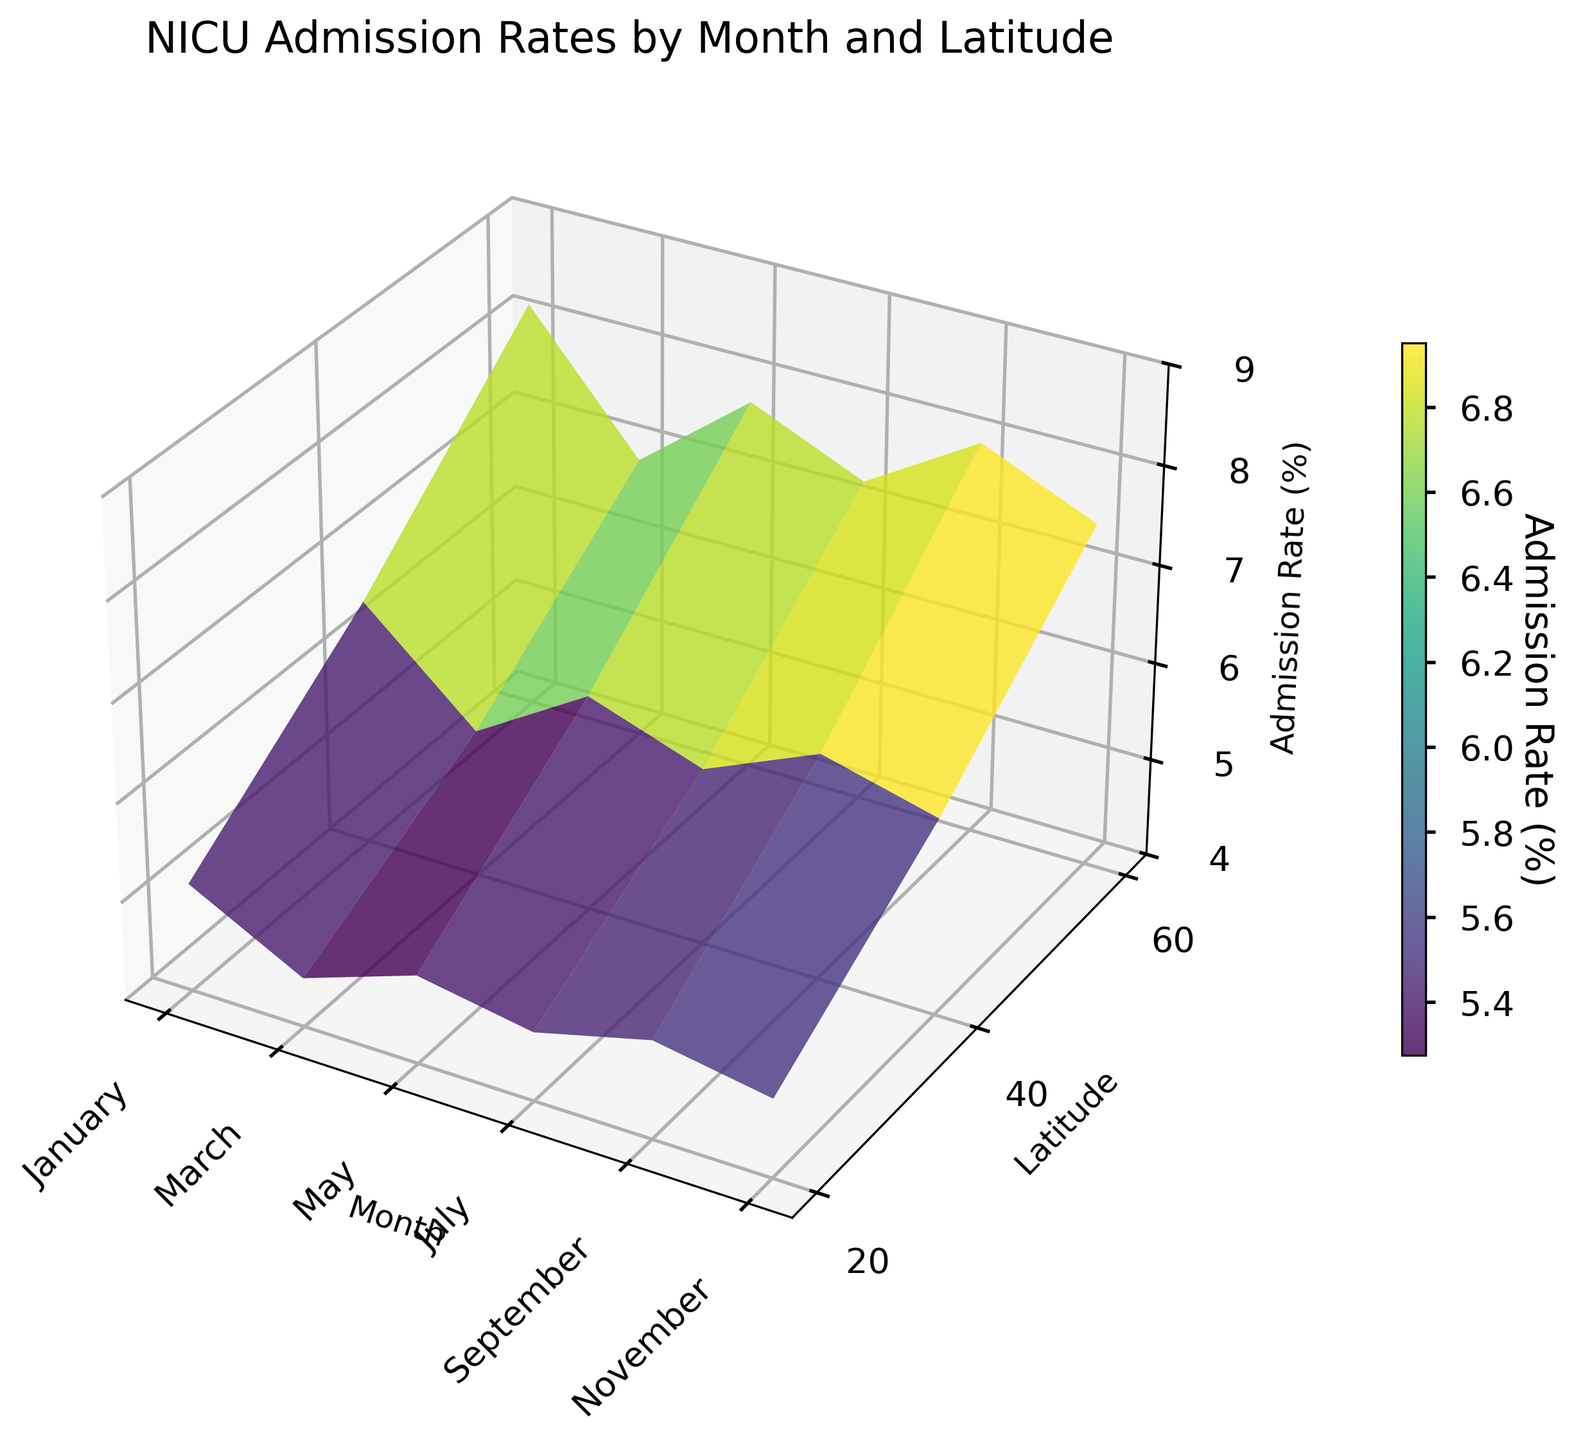What is the title of the figure? The title is located at the top of the figure. It is a descriptive statement summarizing the content of the plot.
Answer: NICU Admission Rates by Month and Latitude What is the admission rate for January at a latitude of 40 degrees? Locate January on the x-axis and 40 degrees on the y-axis, and then identify their intersection point on the plot to find the admission rate.
Answer: 6.5 In which month is the admission rate the highest at a latitude of 60 degrees? Identify the curve corresponding to 60 degrees on the y-axis and compare the peaks for different months. The highest point indicates the month with the highest admission rate.
Answer: January How does the admission rate change with latitude in May? Follow the curve corresponding to May. Comparatively analyze the changes in admission rates across 20, 40, and 60 degrees latitudes.
Answer: It increases as latitude increases Which month shows the lowest overall admission rates across all latitudes? Compare the surfaces for all months and identify the one with the consistently lowest elevation across different latitudes.
Answer: July How much does the admission rate vary between January and July at 60 degrees latitude? Look at the admission rates for January and July at 60 degrees latitude, and find the difference between the two values.
Answer: 1.3 Between which two months is the change in admission rate the greatest at a latitude of 20 degrees? Compare the differences between admission rates for adjacent months at 20 degrees latitude and find the largest difference.
Answer: January to March Which latitude shows the least variation in admission rates across all months? Observe the height differences in the surface plot for 20, 40, and 60 degrees latitudes and identify which has the smallest range.
Answer: 20 degrees What is the average admission rate across all months at a latitude of 40 degrees? Sum the admission rates for all months at 40 degrees latitude and divide by the number of months.
Answer: 6.05 In November, how does the admission rate at a latitude of 20 degrees compare to that at 60 degrees? Locate the admission rates for November at both latitudes and compare their values.
Answer: The rate at 20 degrees is lower 